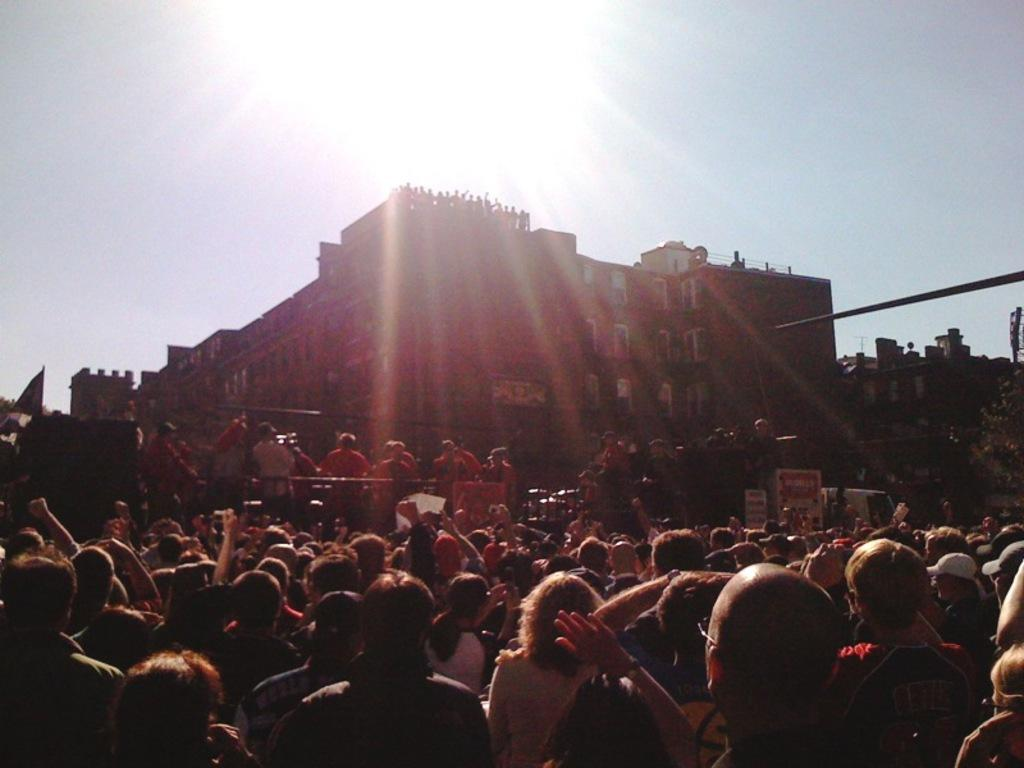What can be seen in the foreground of the image? There are people standing in front of the building. What is the nature of the wire visible in the image? The wire is visible in the image, but its purpose or function is not specified. What is visible in the background of the image? There is a sky visible in the background, and the sun is observable in the sky. What type of prose is being recited by the people in the image? There is no indication in the image that the people are reciting any prose or engaging in any literary activity. 